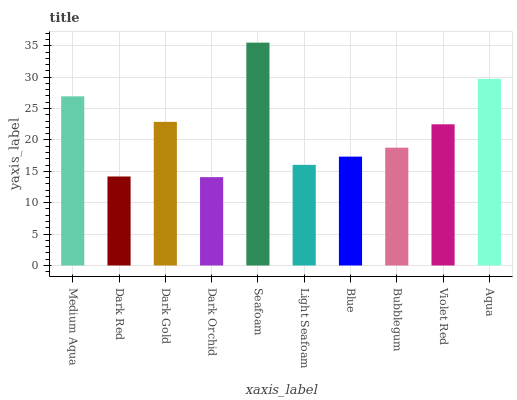Is Dark Orchid the minimum?
Answer yes or no. Yes. Is Seafoam the maximum?
Answer yes or no. Yes. Is Dark Red the minimum?
Answer yes or no. No. Is Dark Red the maximum?
Answer yes or no. No. Is Medium Aqua greater than Dark Red?
Answer yes or no. Yes. Is Dark Red less than Medium Aqua?
Answer yes or no. Yes. Is Dark Red greater than Medium Aqua?
Answer yes or no. No. Is Medium Aqua less than Dark Red?
Answer yes or no. No. Is Violet Red the high median?
Answer yes or no. Yes. Is Bubblegum the low median?
Answer yes or no. Yes. Is Seafoam the high median?
Answer yes or no. No. Is Dark Gold the low median?
Answer yes or no. No. 